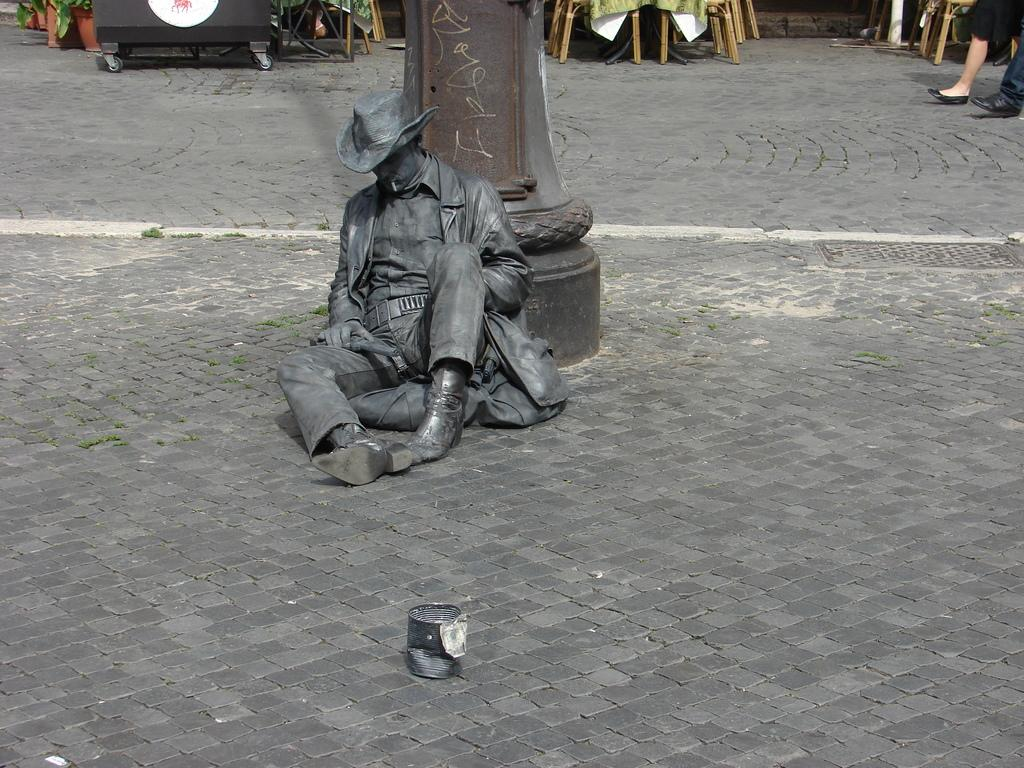What is the main subject of the image? There is a statue of a person in the image. Where is the statue located? The statue is on the ground. What is in front of the statue? There is a tin in front of the statue. What can be seen in the background of the image? There are people's legs and some objects visible in the background. What type of locket is hanging from the statue's neck in the image? There is no locket present on the statue in the image. How many shoes can be seen on the statue's feet in the image? The statue is not a real person, and therefore it does not have feet or shoes. --- Facts: 1. There is a car in the image. 2. The car is red. 3. The car has four wheels. 4. There is a road in the image. 5. The road is paved. Absurd Topics: bird, ocean, mountain Conversation: What is the main subject of the image? There is a car in the image. What color is the car? The car is red. How many wheels does the car have? The car has four wheels. What type of surface is visible in the image? There is a paved road in the image. Reasoning: Let's think step by step in order to produce the conversation. We start by identifying the main subject of the image, which is the car. Then, we describe the car's color and the number of wheels it has. Finally, we mention the type of surface visible in the image, which is a paved road. Each question is designed to elicit a specific detail about the image that is known from the provided facts. Absurd Question/Answer: Can you see any birds flying over the ocean in the image? There is no ocean or birds present in the image; it features a red car on a paved road. What type of mountain range can be seen in the background of the image? There is no mountain range visible in the image; it only shows a red car on a paved road. 